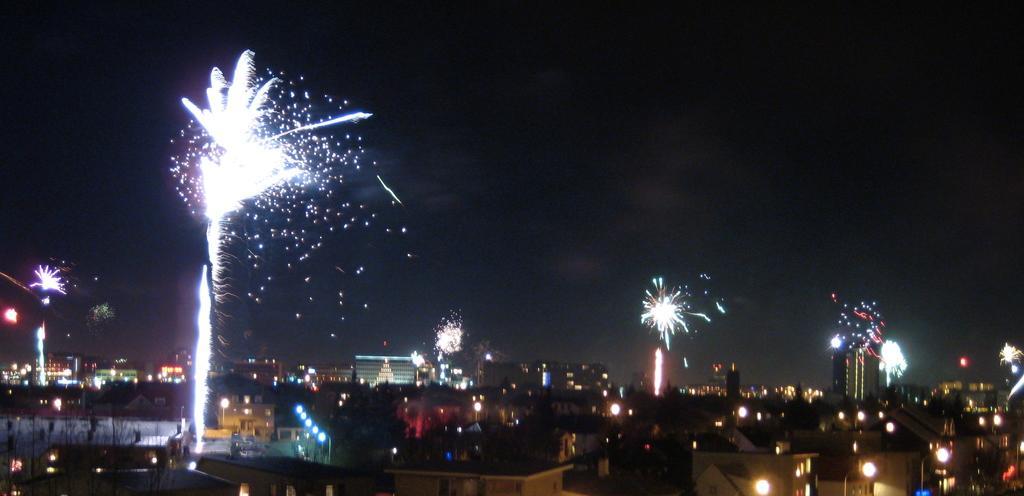Please provide a concise description of this image. In this picture there are few buildings and lightnings. 